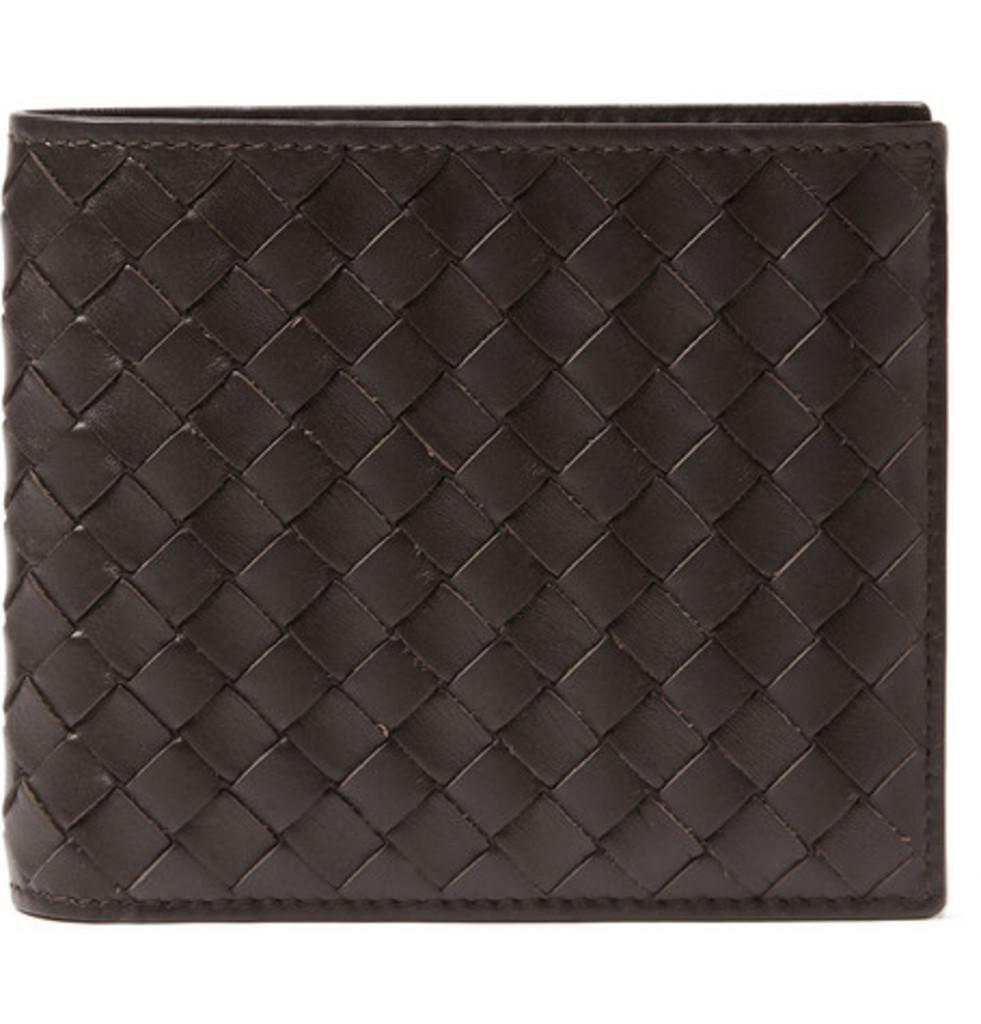Please provide a concise description of this image. This image consists of a wallet in black color. 